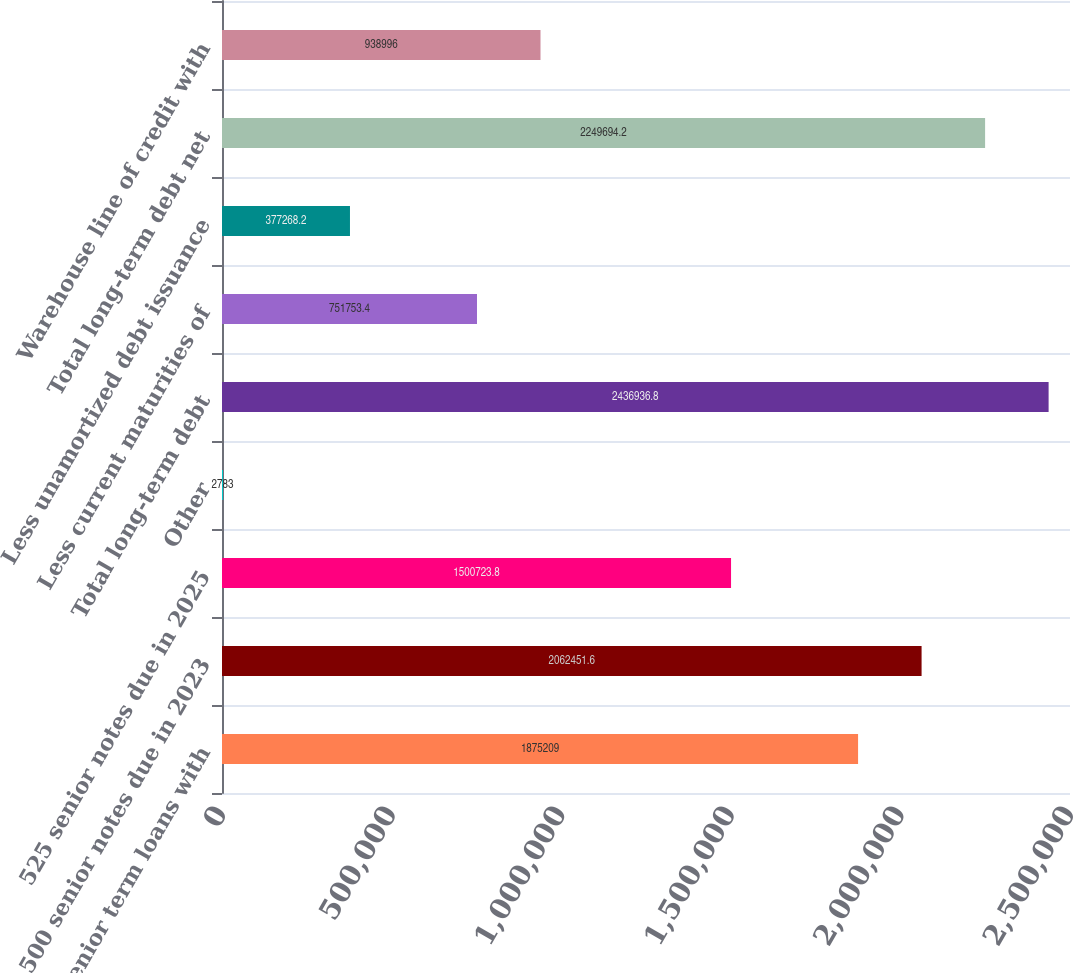<chart> <loc_0><loc_0><loc_500><loc_500><bar_chart><fcel>Senior term loans with<fcel>500 senior notes due in 2023<fcel>525 senior notes due in 2025<fcel>Other<fcel>Total long-term debt<fcel>Less current maturities of<fcel>Less unamortized debt issuance<fcel>Total long-term debt net<fcel>Warehouse line of credit with<nl><fcel>1.87521e+06<fcel>2.06245e+06<fcel>1.50072e+06<fcel>2783<fcel>2.43694e+06<fcel>751753<fcel>377268<fcel>2.24969e+06<fcel>938996<nl></chart> 